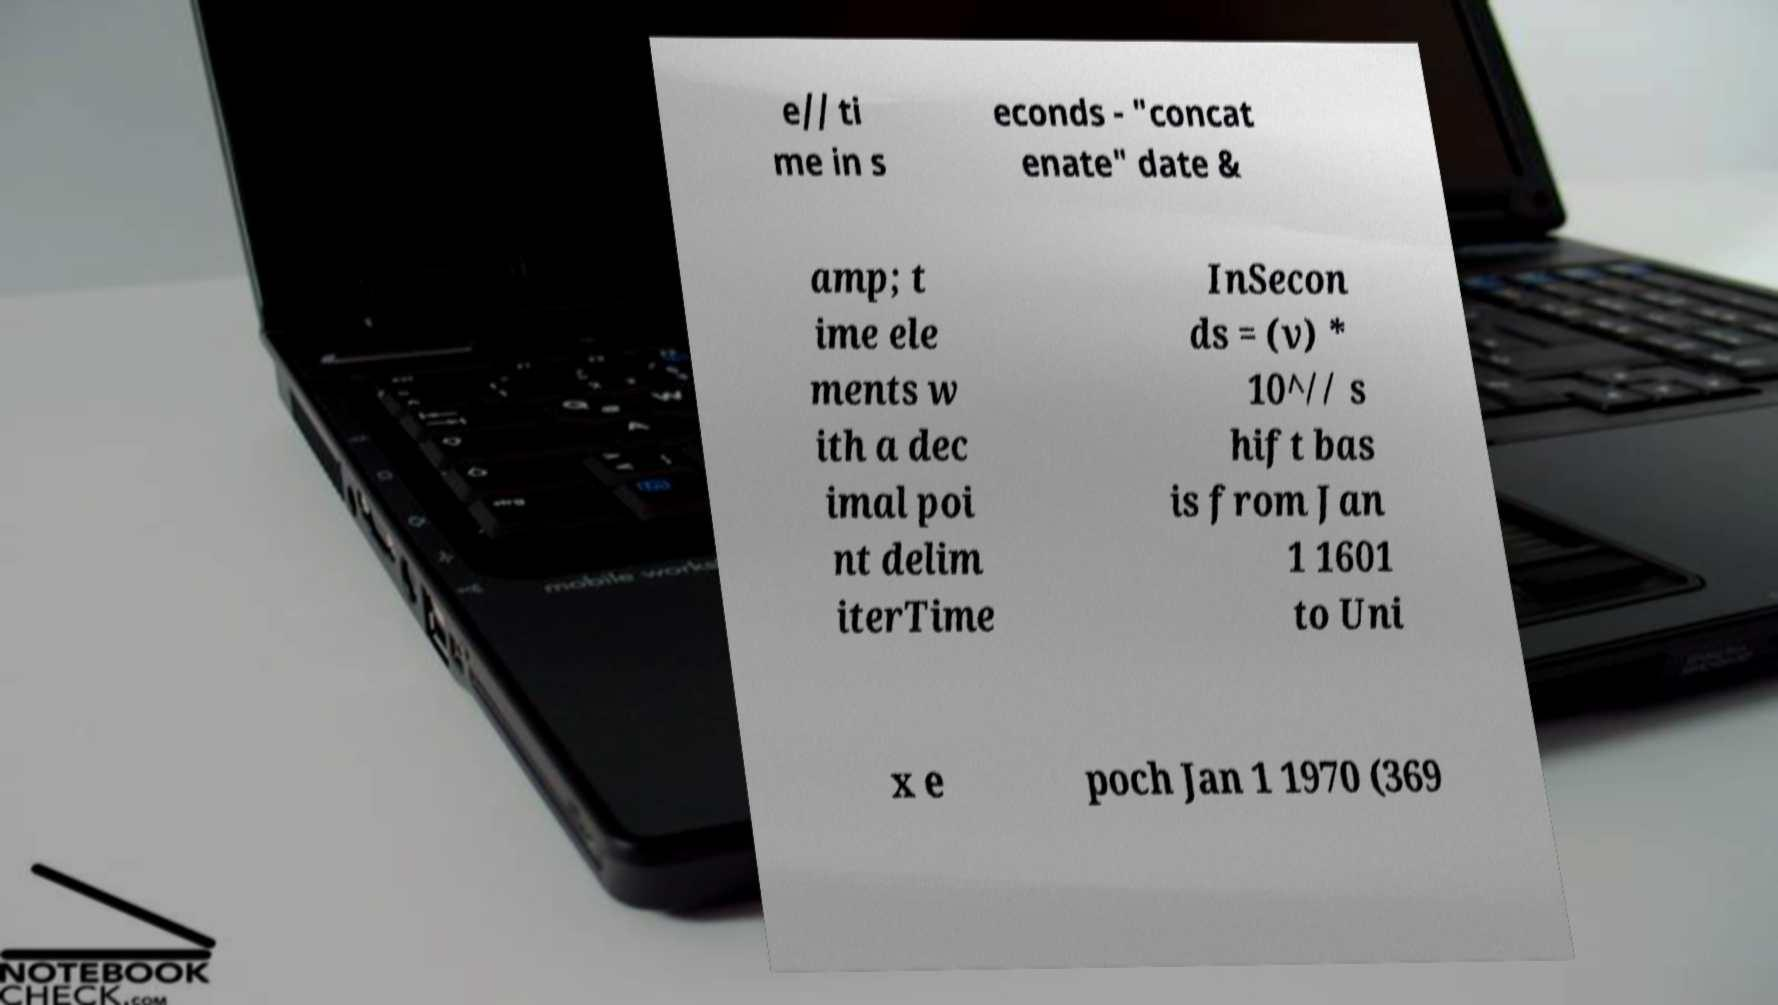Can you read and provide the text displayed in the image?This photo seems to have some interesting text. Can you extract and type it out for me? e// ti me in s econds - "concat enate" date & amp; t ime ele ments w ith a dec imal poi nt delim iterTime InSecon ds = (v) * 10^// s hift bas is from Jan 1 1601 to Uni x e poch Jan 1 1970 (369 